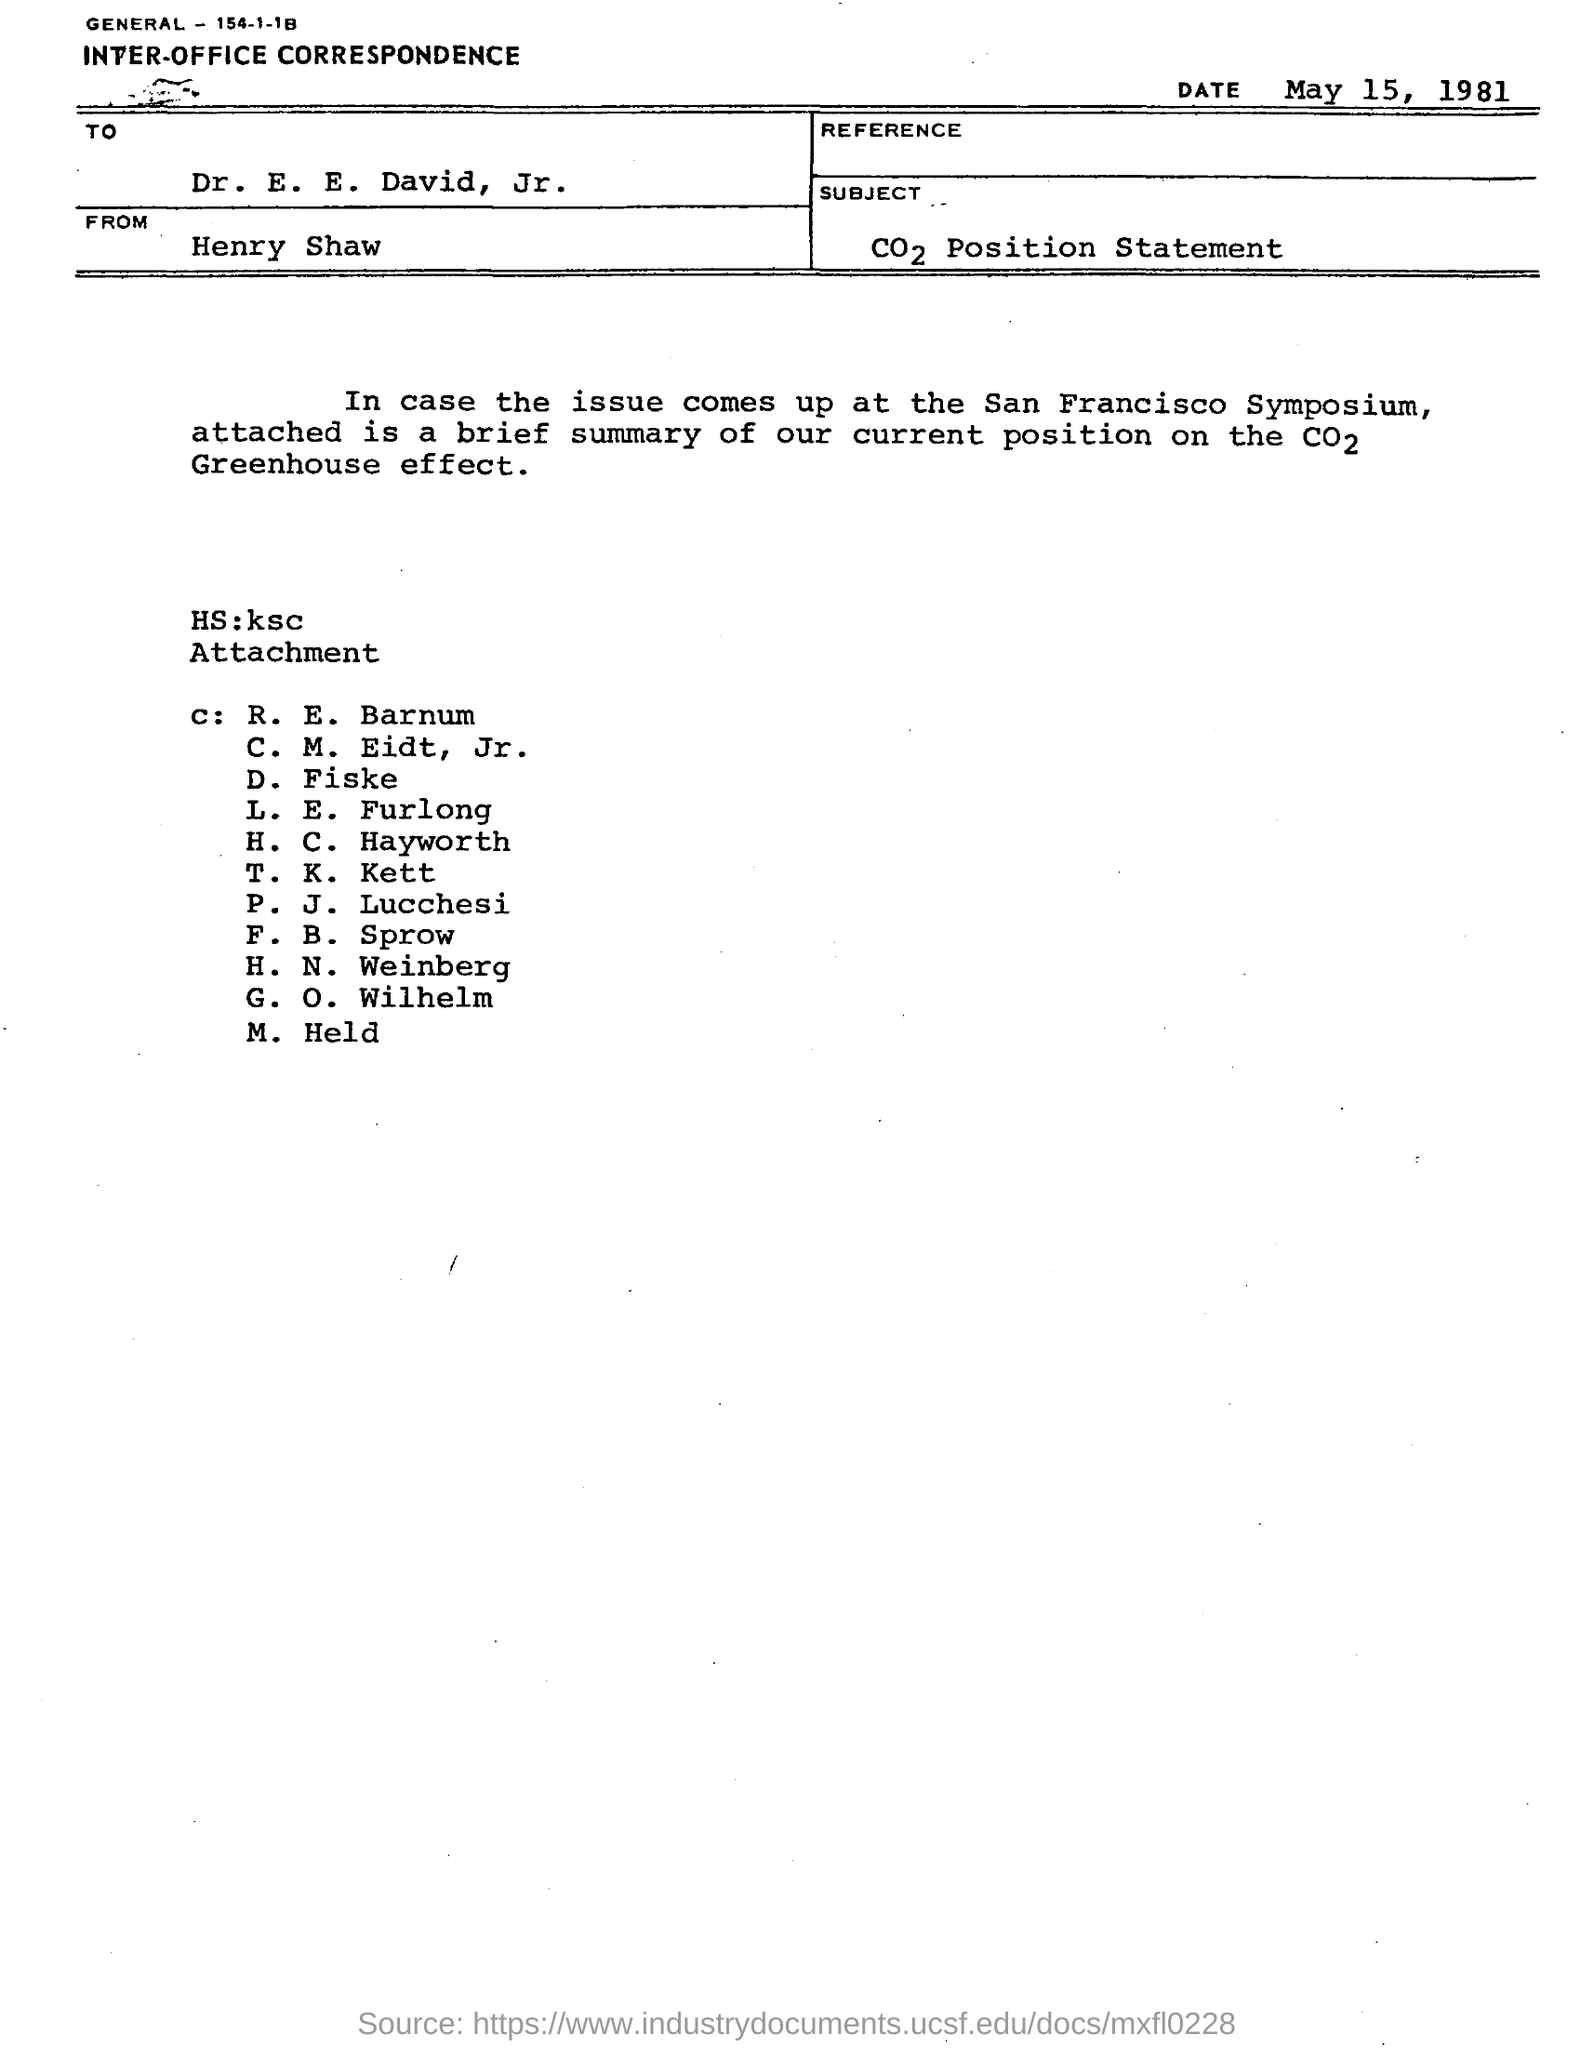Highlight a few significant elements in this photo. The document is addressed to Dr. E. E. David, Jr. The document is dated May 15, 1981. This is an example of inter-office correspondence. The document is from Henry Shaw. 